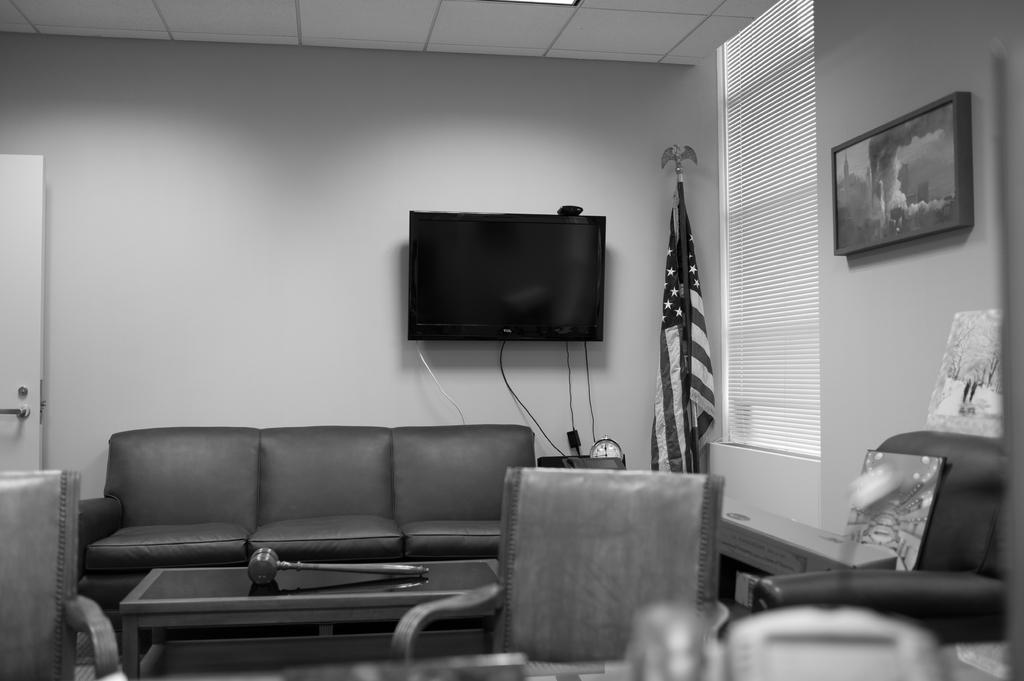What type of furniture is present in the room? There is a chair, a sofa, and a table in the room. What type of entertainment device is in the room? There is a television in the room. What type of decorative item is in the room? There is a wall frame in the room. What type of symbolic item is in the room? There is a flag in the room. What type of rake is used to clean the floor in the room? There is no rake present in the room; it is not a cleaning tool typically used indoors. 